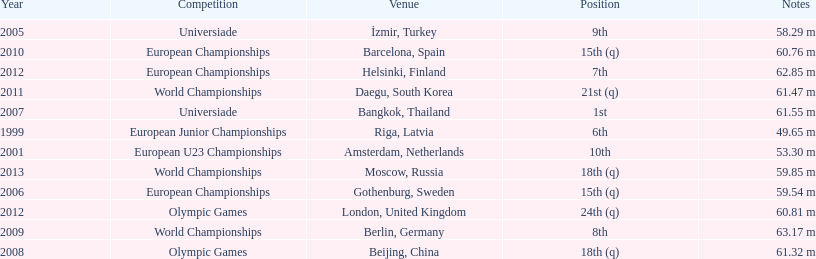What was the last competition he was in before the 2012 olympics? European Championships. 